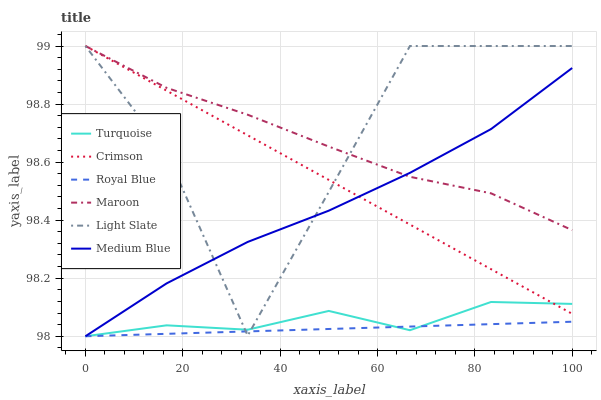Does Royal Blue have the minimum area under the curve?
Answer yes or no. Yes. Does Light Slate have the maximum area under the curve?
Answer yes or no. Yes. Does Medium Blue have the minimum area under the curve?
Answer yes or no. No. Does Medium Blue have the maximum area under the curve?
Answer yes or no. No. Is Crimson the smoothest?
Answer yes or no. Yes. Is Light Slate the roughest?
Answer yes or no. Yes. Is Medium Blue the smoothest?
Answer yes or no. No. Is Medium Blue the roughest?
Answer yes or no. No. Does Turquoise have the lowest value?
Answer yes or no. Yes. Does Light Slate have the lowest value?
Answer yes or no. No. Does Crimson have the highest value?
Answer yes or no. Yes. Does Medium Blue have the highest value?
Answer yes or no. No. Is Turquoise less than Maroon?
Answer yes or no. Yes. Is Maroon greater than Royal Blue?
Answer yes or no. Yes. Does Maroon intersect Light Slate?
Answer yes or no. Yes. Is Maroon less than Light Slate?
Answer yes or no. No. Is Maroon greater than Light Slate?
Answer yes or no. No. Does Turquoise intersect Maroon?
Answer yes or no. No. 